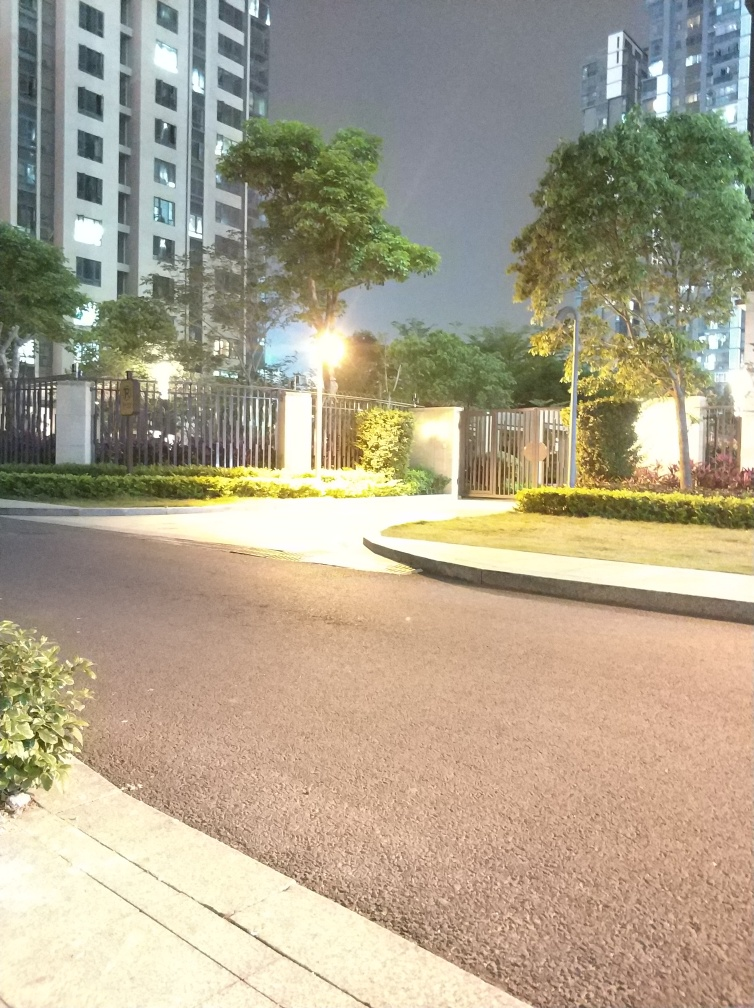What time of day does this image seem to have been captured, and what are the clues to that? The image appears to have been taken at night. The clues include the darkness of the sky, the artificial lighting illuminating the area, and the absence of natural light. 